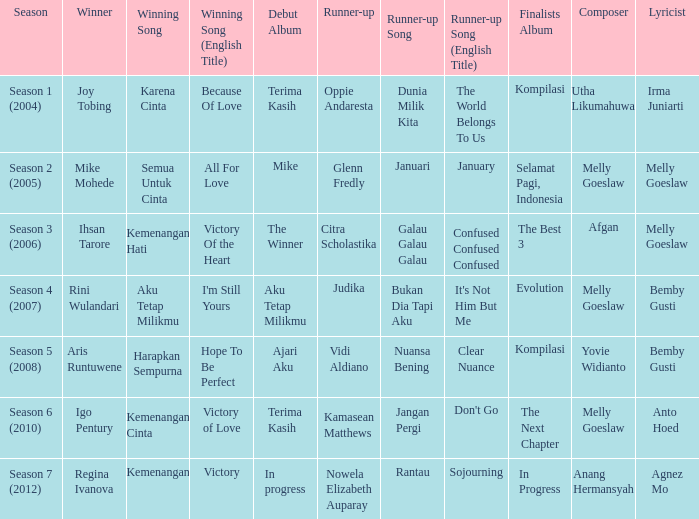Who won with the song kemenangan cinta? Igo Pentury. 